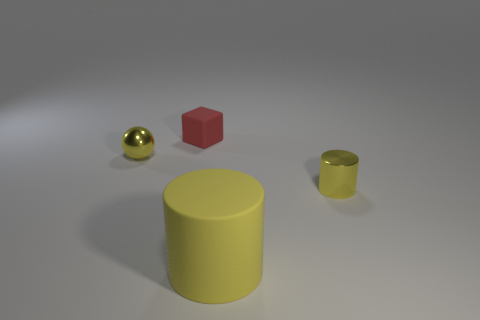Add 4 yellow balls. How many objects exist? 8 Subtract all spheres. How many objects are left? 3 Add 3 shiny cylinders. How many shiny cylinders are left? 4 Add 4 red matte cubes. How many red matte cubes exist? 5 Subtract 0 green cubes. How many objects are left? 4 Subtract all big purple cubes. Subtract all small red things. How many objects are left? 3 